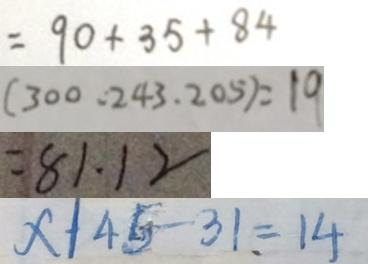Convert formula to latex. <formula><loc_0><loc_0><loc_500><loc_500>= 9 0 + 3 5 + 8 4 
 ( 3 0 0 . 2 4 3 . 2 0 5 ) = 1 9 
 = 8 1 . 1 2 
 x \vert 4 5 - 3 1 = 1 4</formula> 